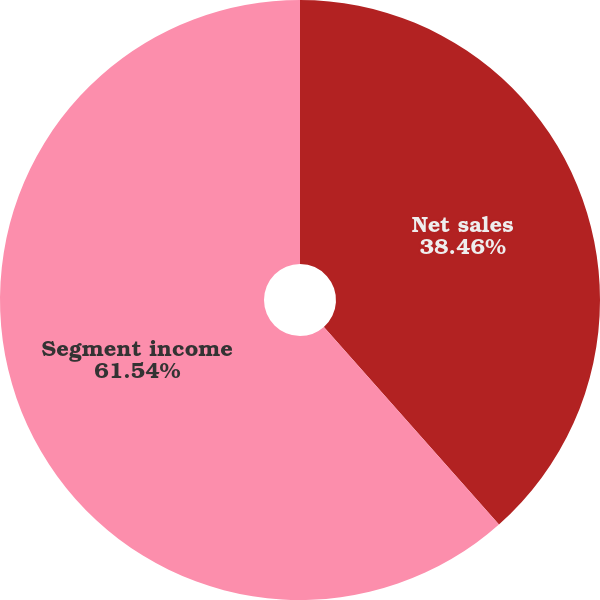<chart> <loc_0><loc_0><loc_500><loc_500><pie_chart><fcel>Net sales<fcel>Segment income<nl><fcel>38.46%<fcel>61.54%<nl></chart> 